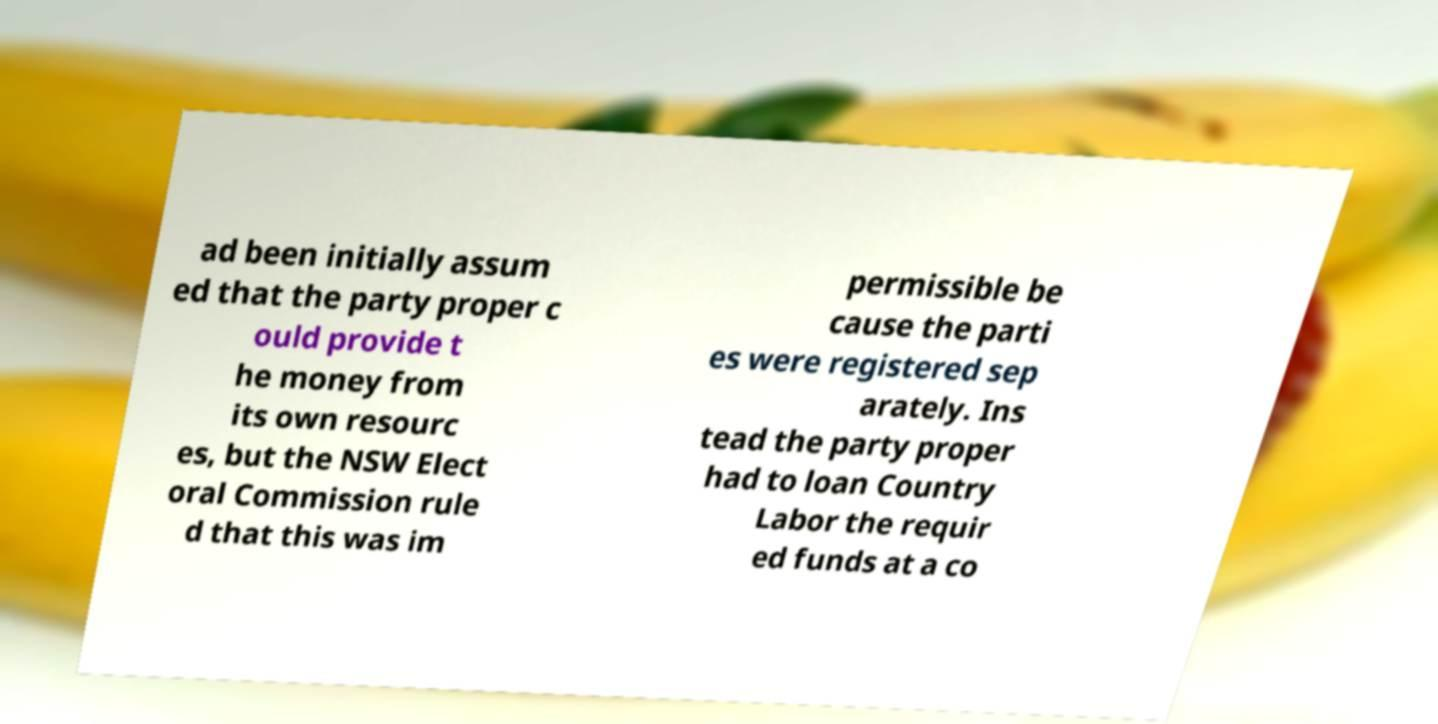Can you accurately transcribe the text from the provided image for me? ad been initially assum ed that the party proper c ould provide t he money from its own resourc es, but the NSW Elect oral Commission rule d that this was im permissible be cause the parti es were registered sep arately. Ins tead the party proper had to loan Country Labor the requir ed funds at a co 